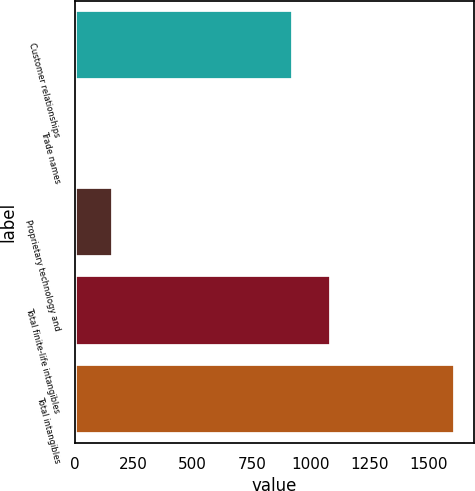<chart> <loc_0><loc_0><loc_500><loc_500><bar_chart><fcel>Customer relationships<fcel>Trade names<fcel>Proprietary technology and<fcel>Total finite-life intangibles<fcel>Total intangibles<nl><fcel>922.6<fcel>0.9<fcel>161.62<fcel>1083.32<fcel>1608.1<nl></chart> 